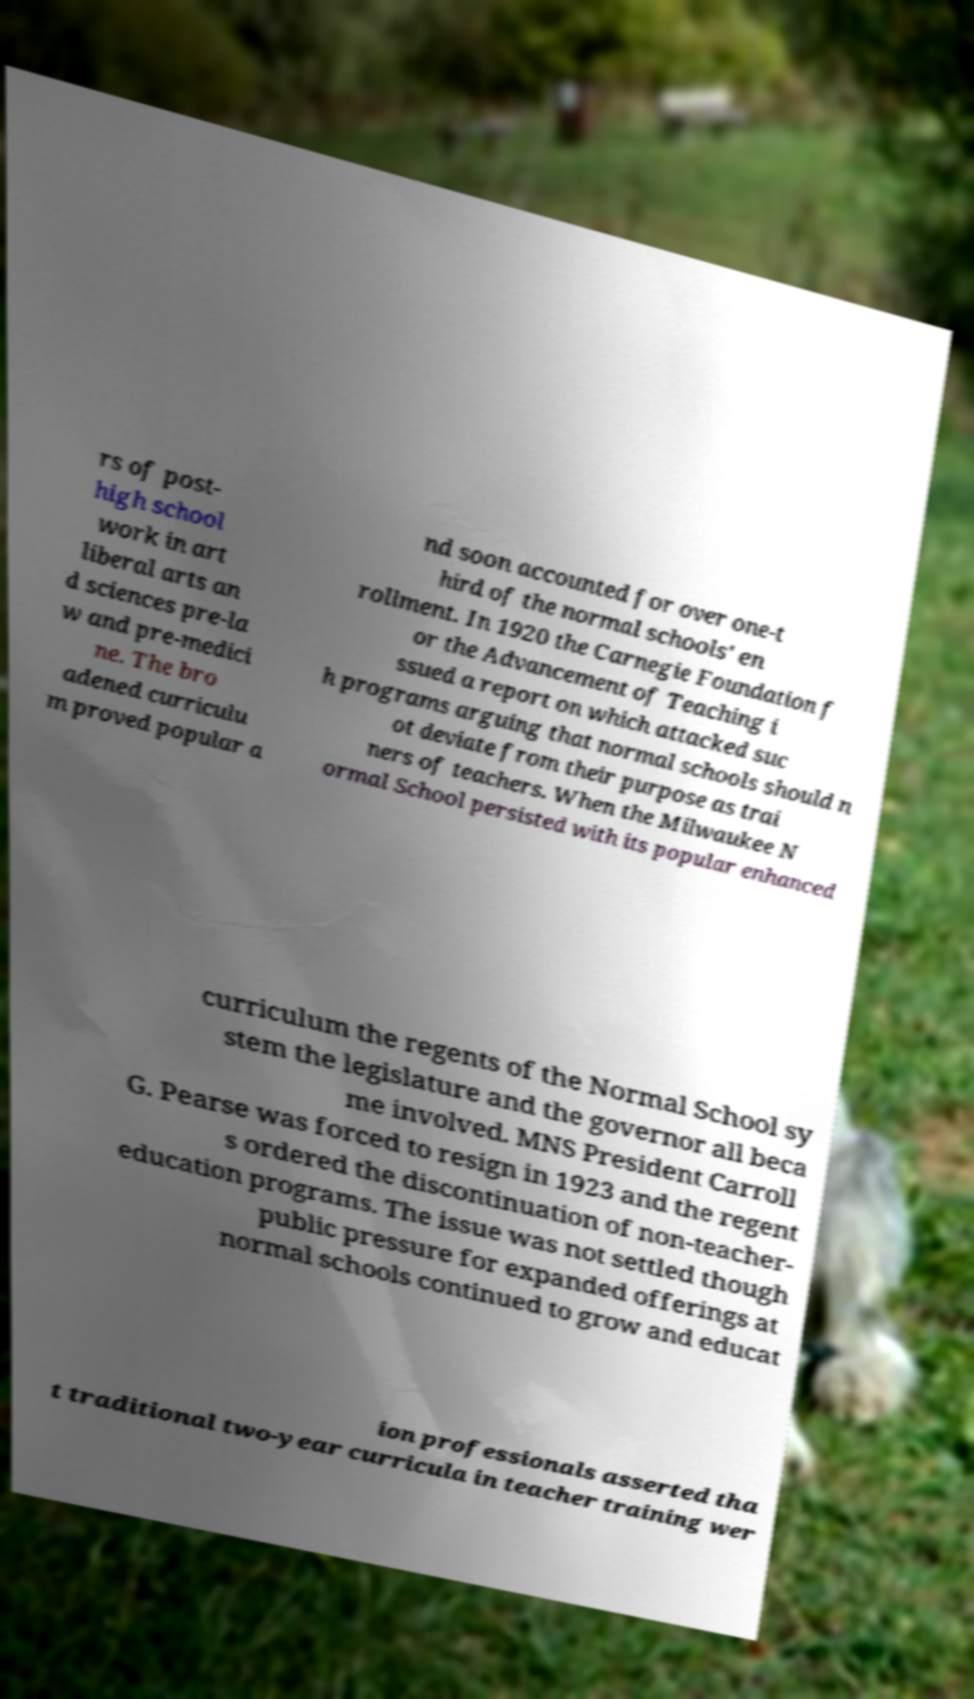There's text embedded in this image that I need extracted. Can you transcribe it verbatim? rs of post- high school work in art liberal arts an d sciences pre-la w and pre-medici ne. The bro adened curriculu m proved popular a nd soon accounted for over one-t hird of the normal schools' en rollment. In 1920 the Carnegie Foundation f or the Advancement of Teaching i ssued a report on which attacked suc h programs arguing that normal schools should n ot deviate from their purpose as trai ners of teachers. When the Milwaukee N ormal School persisted with its popular enhanced curriculum the regents of the Normal School sy stem the legislature and the governor all beca me involved. MNS President Carroll G. Pearse was forced to resign in 1923 and the regent s ordered the discontinuation of non-teacher- education programs. The issue was not settled though public pressure for expanded offerings at normal schools continued to grow and educat ion professionals asserted tha t traditional two-year curricula in teacher training wer 